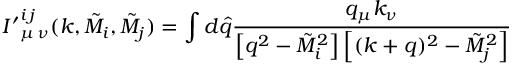<formula> <loc_0><loc_0><loc_500><loc_500>{ I ^ { \prime } } _ { \mu \, \nu } ^ { i \, j } ( k , \tilde { M } _ { i } , \tilde { M } _ { j } ) = \int d \widehat { q } \frac { q _ { \mu } k _ { \nu } } { \left [ q ^ { 2 } - \tilde { M } _ { i } ^ { 2 } \right ] \left [ ( k + q ) ^ { 2 } - \tilde { M } _ { j } ^ { 2 } \right ] }</formula> 